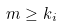<formula> <loc_0><loc_0><loc_500><loc_500>m \geq k _ { i }</formula> 